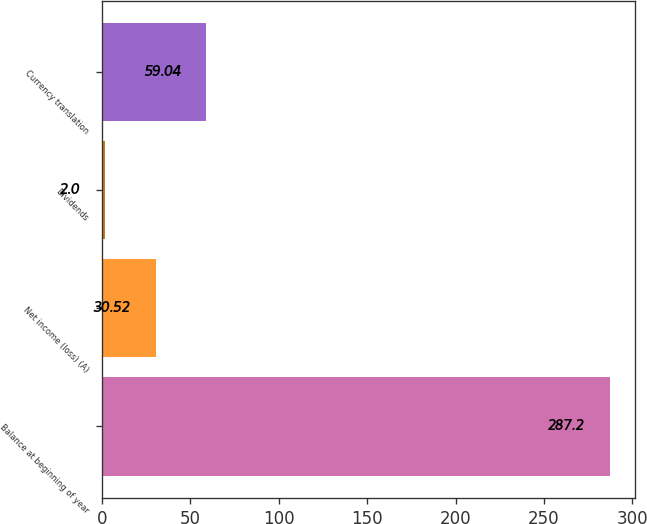Convert chart to OTSL. <chart><loc_0><loc_0><loc_500><loc_500><bar_chart><fcel>Balance at beginning of year<fcel>Net income (loss) (A)<fcel>Dividends<fcel>Currency translation<nl><fcel>287.2<fcel>30.52<fcel>2<fcel>59.04<nl></chart> 